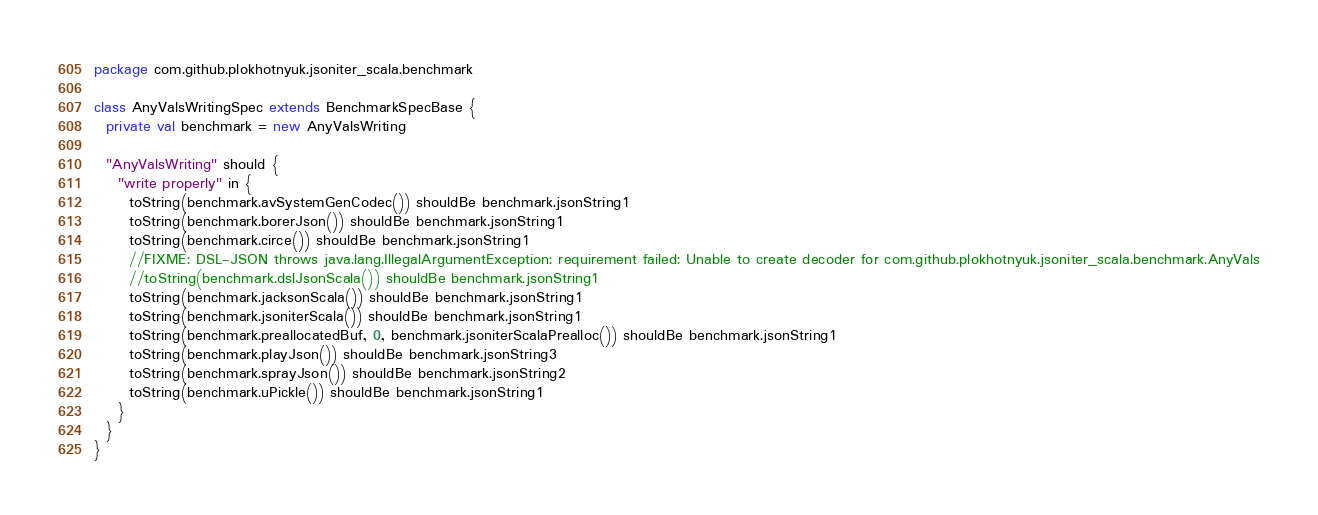<code> <loc_0><loc_0><loc_500><loc_500><_Scala_>package com.github.plokhotnyuk.jsoniter_scala.benchmark

class AnyValsWritingSpec extends BenchmarkSpecBase {
  private val benchmark = new AnyValsWriting
  
  "AnyValsWriting" should {
    "write properly" in {
      toString(benchmark.avSystemGenCodec()) shouldBe benchmark.jsonString1
      toString(benchmark.borerJson()) shouldBe benchmark.jsonString1
      toString(benchmark.circe()) shouldBe benchmark.jsonString1
      //FIXME: DSL-JSON throws java.lang.IllegalArgumentException: requirement failed: Unable to create decoder for com.github.plokhotnyuk.jsoniter_scala.benchmark.AnyVals
      //toString(benchmark.dslJsonScala()) shouldBe benchmark.jsonString1
      toString(benchmark.jacksonScala()) shouldBe benchmark.jsonString1
      toString(benchmark.jsoniterScala()) shouldBe benchmark.jsonString1
      toString(benchmark.preallocatedBuf, 0, benchmark.jsoniterScalaPrealloc()) shouldBe benchmark.jsonString1
      toString(benchmark.playJson()) shouldBe benchmark.jsonString3
      toString(benchmark.sprayJson()) shouldBe benchmark.jsonString2
      toString(benchmark.uPickle()) shouldBe benchmark.jsonString1
    }
  }
}</code> 